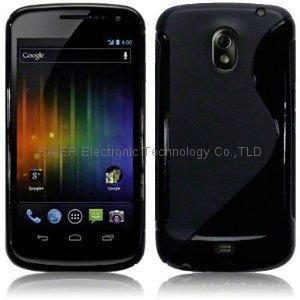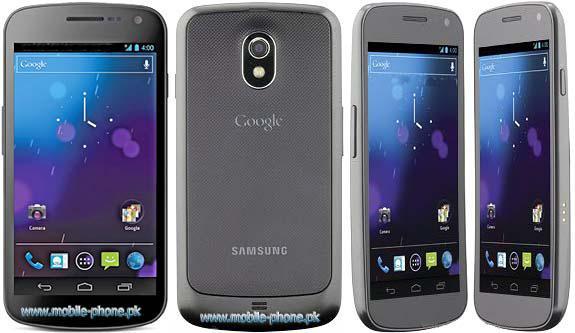The first image is the image on the left, the second image is the image on the right. Examine the images to the left and right. Is the description "There is no less than five phones." accurate? Answer yes or no. Yes. The first image is the image on the left, the second image is the image on the right. Given the left and right images, does the statement "There are no less than five phones." hold true? Answer yes or no. Yes. 